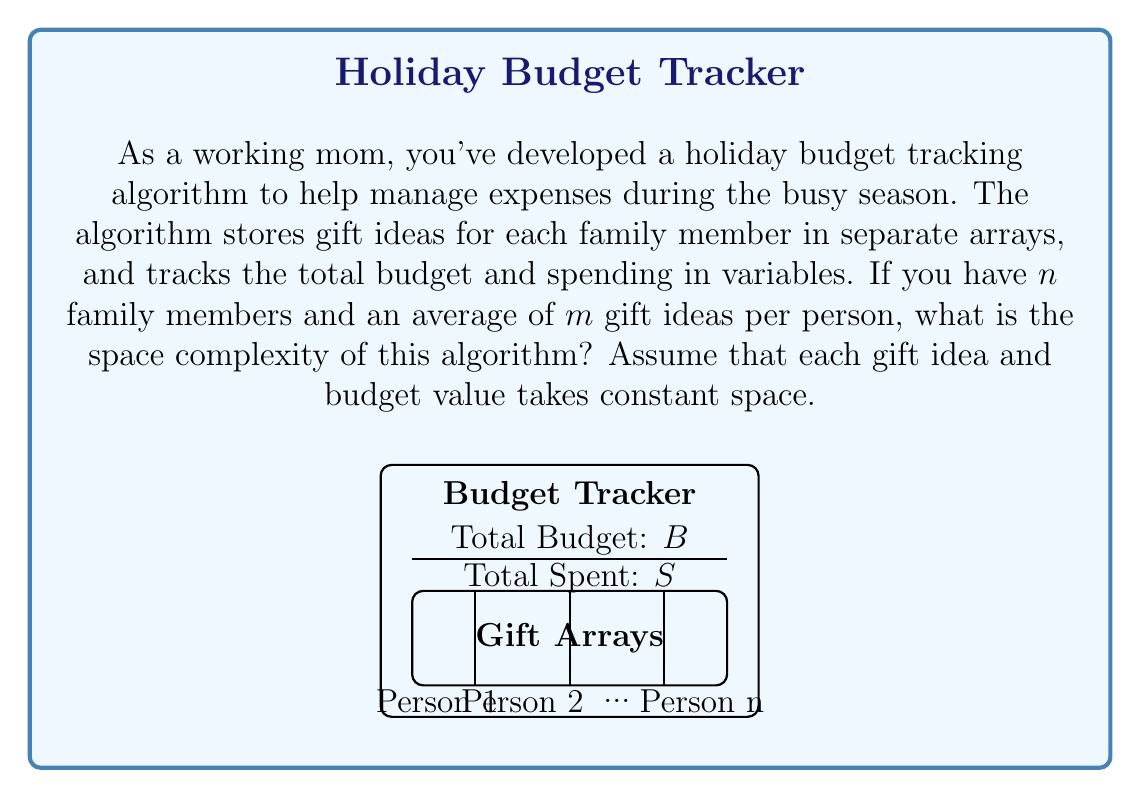Show me your answer to this math problem. Let's analyze the space complexity of this holiday budget tracking algorithm step by step:

1) First, we need to consider the space used by the constant variables:
   - Total budget: $O(1)$
   - Total spent: $O(1)$

2) Next, we look at the space used by the gift idea arrays:
   - There are $n$ family members
   - Each family member has an average of $m$ gift ideas
   - So, there are $n$ arrays, each containing $m$ elements on average

3) The total space used by the gift idea arrays is:
   $n \times m = O(nm)$

4) Now, we combine the space used by constants and arrays:
   $O(1) + O(1) + O(nm) = O(nm)$

5) The dominant term in this expression is $O(nm)$, so this becomes our final space complexity.

The space complexity grows linearly with both the number of family members and the average number of gift ideas per person. This is because we're storing a separate list of gift ideas for each family member.
Answer: $O(nm)$ 